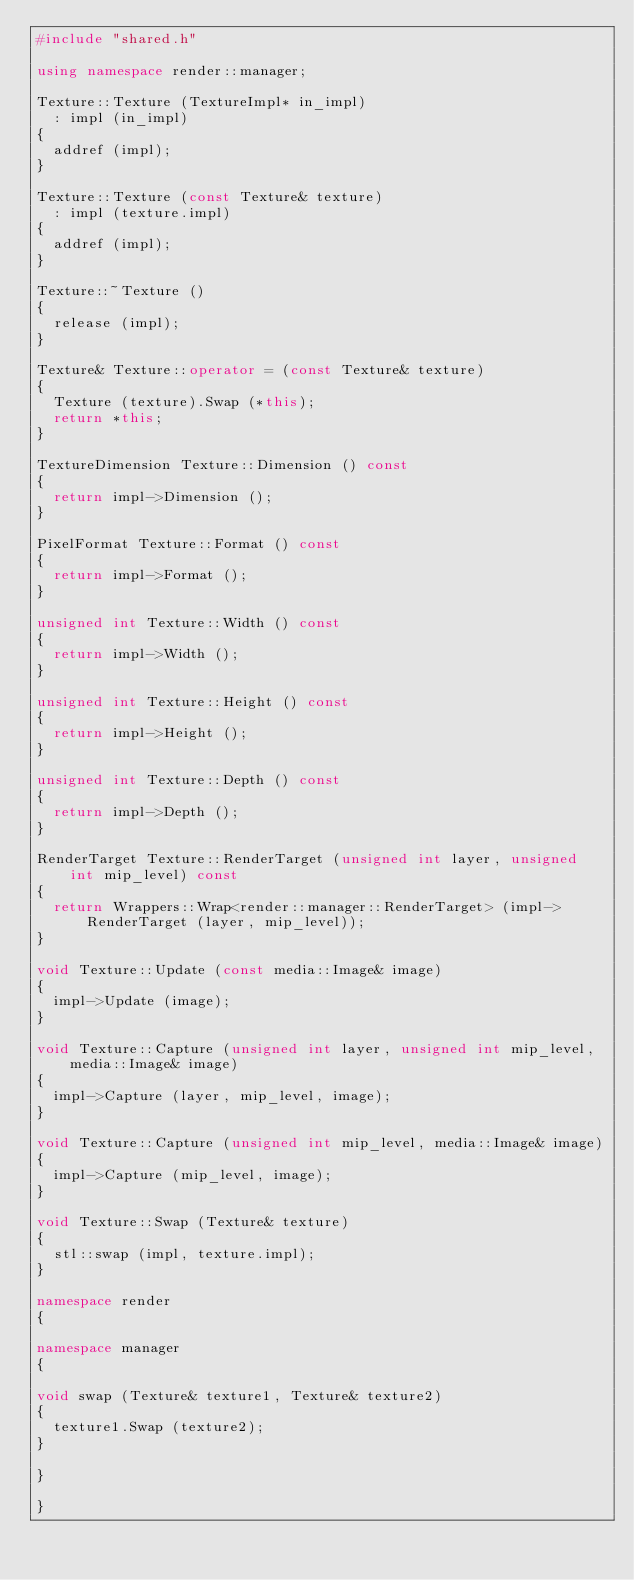Convert code to text. <code><loc_0><loc_0><loc_500><loc_500><_C++_>#include "shared.h"

using namespace render::manager;

Texture::Texture (TextureImpl* in_impl)
  : impl (in_impl)
{
  addref (impl);
}

Texture::Texture (const Texture& texture)
  : impl (texture.impl)
{
  addref (impl);
}

Texture::~Texture ()
{
  release (impl);
}

Texture& Texture::operator = (const Texture& texture)
{
  Texture (texture).Swap (*this);
  return *this;
}

TextureDimension Texture::Dimension () const
{
  return impl->Dimension ();
}

PixelFormat Texture::Format () const
{
  return impl->Format ();
}

unsigned int Texture::Width () const
{
  return impl->Width ();
}

unsigned int Texture::Height () const
{
  return impl->Height ();
}

unsigned int Texture::Depth () const
{
  return impl->Depth ();
}

RenderTarget Texture::RenderTarget (unsigned int layer, unsigned int mip_level) const
{
  return Wrappers::Wrap<render::manager::RenderTarget> (impl->RenderTarget (layer, mip_level));
}

void Texture::Update (const media::Image& image)
{
  impl->Update (image);
}

void Texture::Capture (unsigned int layer, unsigned int mip_level, media::Image& image)
{
  impl->Capture (layer, mip_level, image);
}

void Texture::Capture (unsigned int mip_level, media::Image& image)
{
  impl->Capture (mip_level, image);
}

void Texture::Swap (Texture& texture)
{
  stl::swap (impl, texture.impl);
}

namespace render
{

namespace manager
{

void swap (Texture& texture1, Texture& texture2)
{
  texture1.Swap (texture2);
}

}

}
</code> 